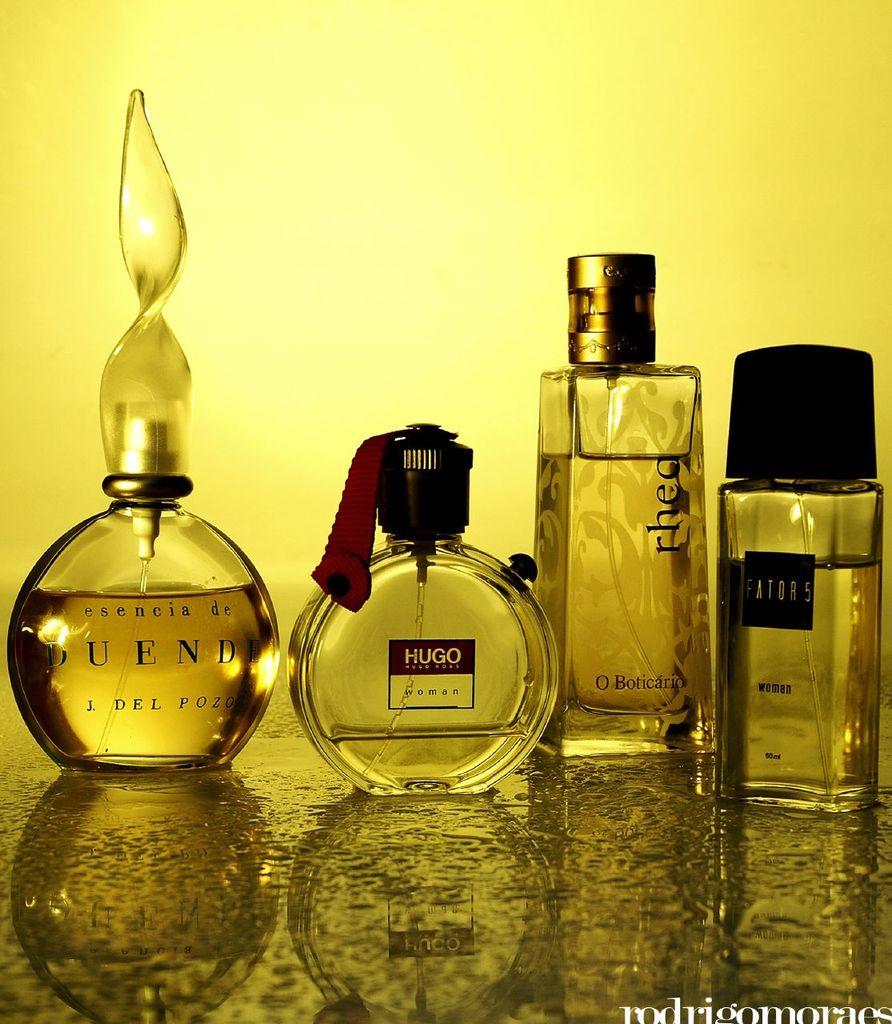Is there a hugo bottle?
Your response must be concise. Yes. Are these for men or women?
Give a very brief answer. Women. 